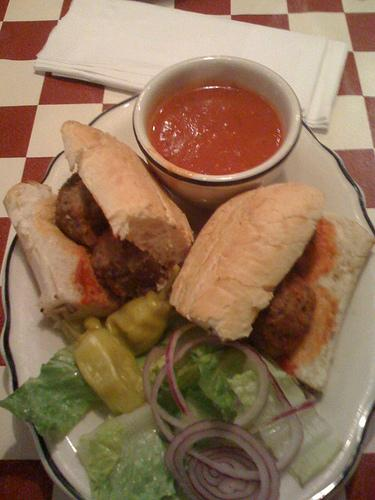What type of pepper is on the plate? pepperoncini 